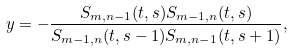Convert formula to latex. <formula><loc_0><loc_0><loc_500><loc_500>y = - \frac { S _ { m , n - 1 } ( t , s ) S _ { m - 1 , n } ( t , s ) } { S _ { m - 1 , n } ( t , s - 1 ) S _ { m , n - 1 } ( t , s + 1 ) } ,</formula> 